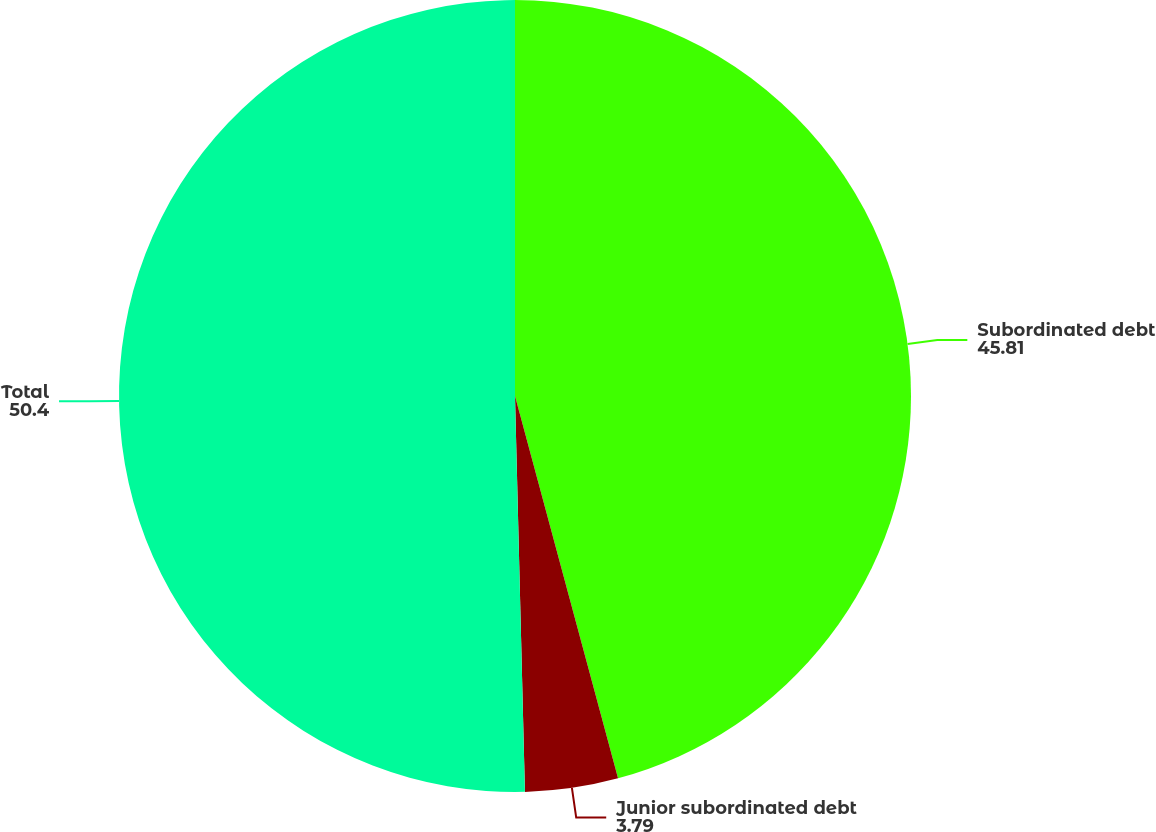Convert chart. <chart><loc_0><loc_0><loc_500><loc_500><pie_chart><fcel>Subordinated debt<fcel>Junior subordinated debt<fcel>Total<nl><fcel>45.81%<fcel>3.79%<fcel>50.4%<nl></chart> 